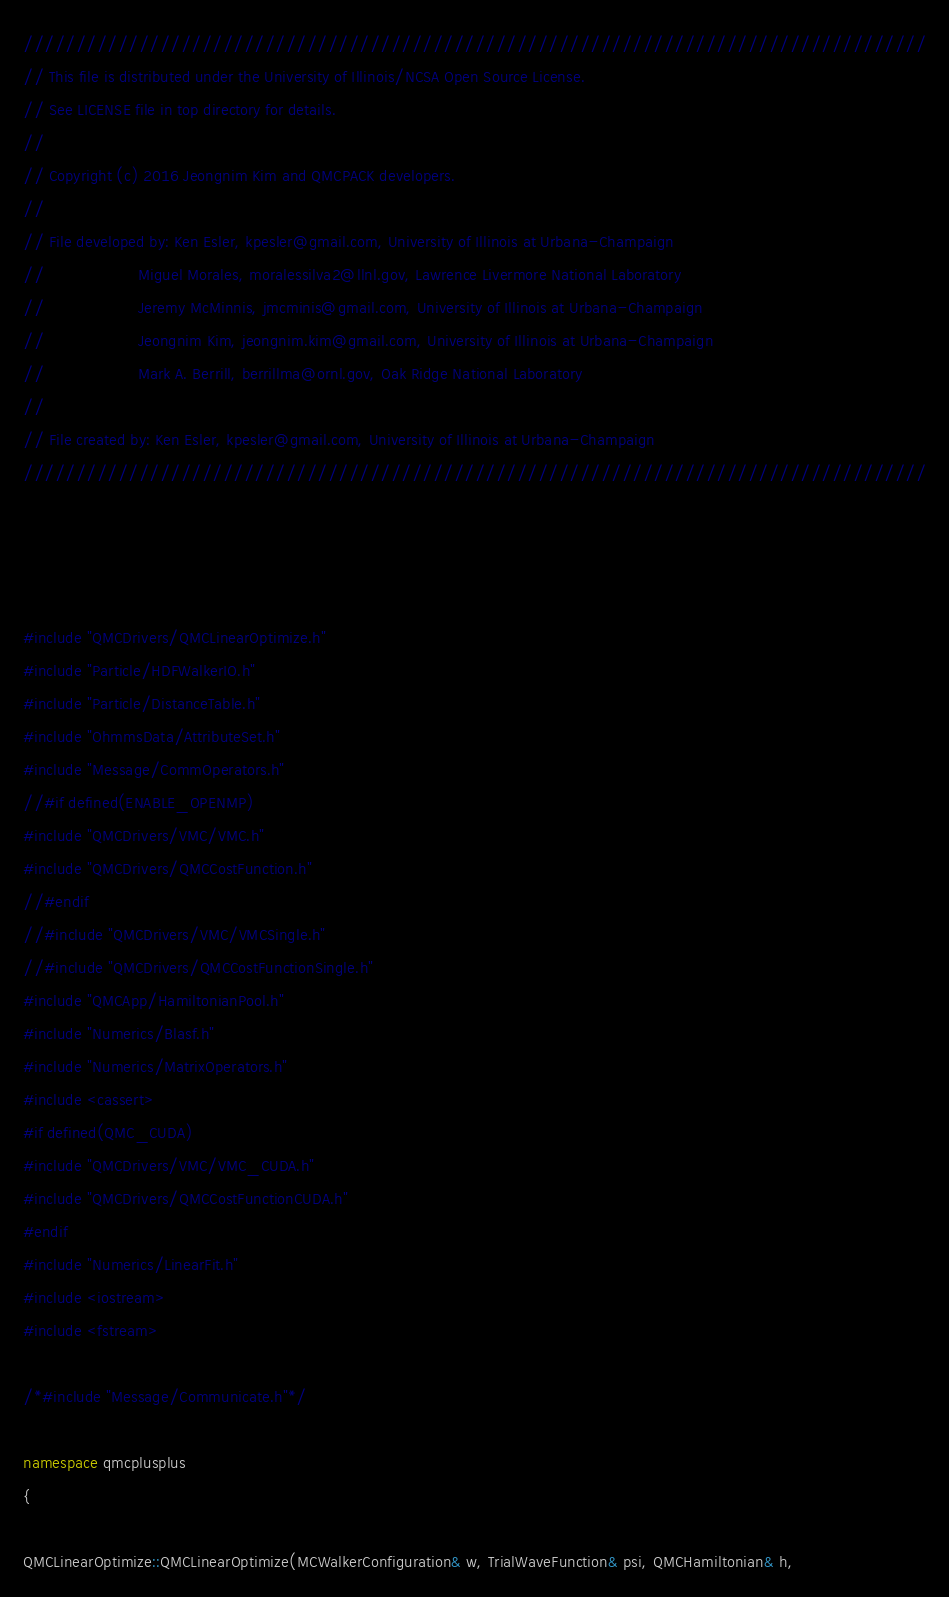<code> <loc_0><loc_0><loc_500><loc_500><_C++_>//////////////////////////////////////////////////////////////////////////////////////
// This file is distributed under the University of Illinois/NCSA Open Source License.
// See LICENSE file in top directory for details.
//
// Copyright (c) 2016 Jeongnim Kim and QMCPACK developers.
//
// File developed by: Ken Esler, kpesler@gmail.com, University of Illinois at Urbana-Champaign
//                    Miguel Morales, moralessilva2@llnl.gov, Lawrence Livermore National Laboratory
//                    Jeremy McMinnis, jmcminis@gmail.com, University of Illinois at Urbana-Champaign
//                    Jeongnim Kim, jeongnim.kim@gmail.com, University of Illinois at Urbana-Champaign
//                    Mark A. Berrill, berrillma@ornl.gov, Oak Ridge National Laboratory
//
// File created by: Ken Esler, kpesler@gmail.com, University of Illinois at Urbana-Champaign
//////////////////////////////////////////////////////////////////////////////////////
    
    


#include "QMCDrivers/QMCLinearOptimize.h"
#include "Particle/HDFWalkerIO.h"
#include "Particle/DistanceTable.h"
#include "OhmmsData/AttributeSet.h"
#include "Message/CommOperators.h"
//#if defined(ENABLE_OPENMP)
#include "QMCDrivers/VMC/VMC.h"
#include "QMCDrivers/QMCCostFunction.h"
//#endif
//#include "QMCDrivers/VMC/VMCSingle.h"
//#include "QMCDrivers/QMCCostFunctionSingle.h"
#include "QMCApp/HamiltonianPool.h"
#include "Numerics/Blasf.h"
#include "Numerics/MatrixOperators.h"
#include <cassert>
#if defined(QMC_CUDA)
#include "QMCDrivers/VMC/VMC_CUDA.h"
#include "QMCDrivers/QMCCostFunctionCUDA.h"
#endif
#include "Numerics/LinearFit.h"
#include <iostream>
#include <fstream>

/*#include "Message/Communicate.h"*/

namespace qmcplusplus
{

QMCLinearOptimize::QMCLinearOptimize(MCWalkerConfiguration& w, TrialWaveFunction& psi, QMCHamiltonian& h,</code> 